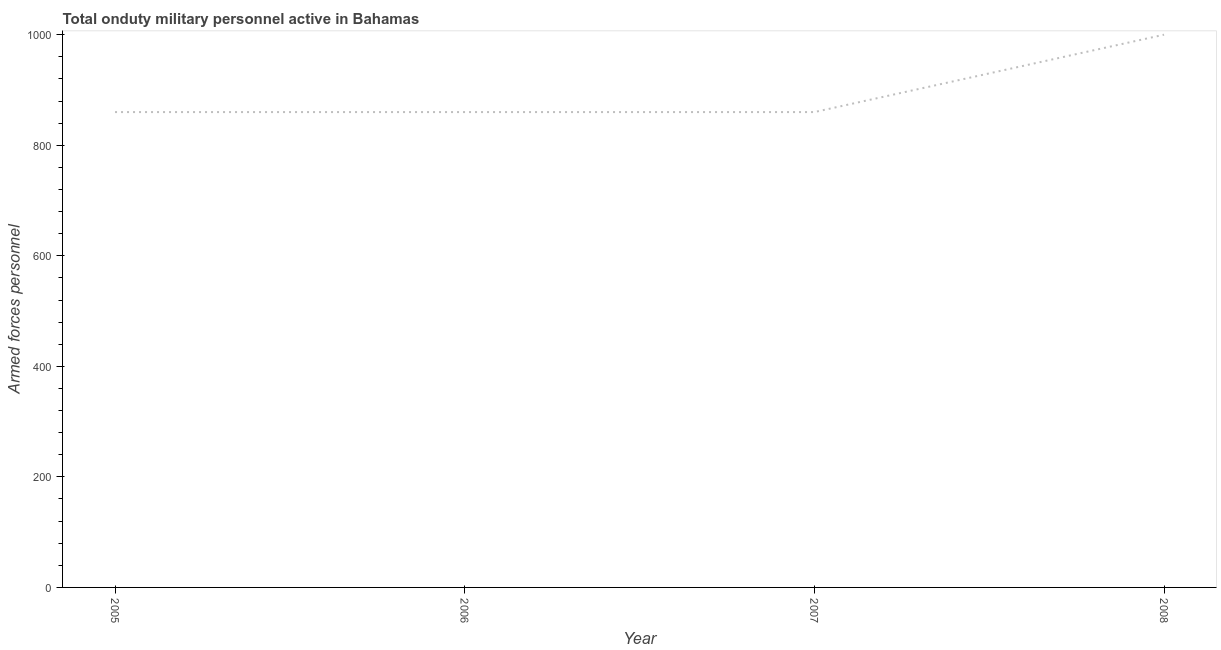What is the number of armed forces personnel in 2006?
Keep it short and to the point. 860. Across all years, what is the maximum number of armed forces personnel?
Your answer should be very brief. 1000. Across all years, what is the minimum number of armed forces personnel?
Ensure brevity in your answer.  860. In which year was the number of armed forces personnel maximum?
Provide a succinct answer. 2008. In which year was the number of armed forces personnel minimum?
Keep it short and to the point. 2005. What is the sum of the number of armed forces personnel?
Your answer should be very brief. 3580. What is the difference between the number of armed forces personnel in 2005 and 2006?
Give a very brief answer. 0. What is the average number of armed forces personnel per year?
Your answer should be compact. 895. What is the median number of armed forces personnel?
Your response must be concise. 860. In how many years, is the number of armed forces personnel greater than 440 ?
Your response must be concise. 4. What is the ratio of the number of armed forces personnel in 2005 to that in 2006?
Give a very brief answer. 1. What is the difference between the highest and the second highest number of armed forces personnel?
Provide a succinct answer. 140. What is the difference between the highest and the lowest number of armed forces personnel?
Make the answer very short. 140. Does the number of armed forces personnel monotonically increase over the years?
Provide a short and direct response. No. Are the values on the major ticks of Y-axis written in scientific E-notation?
Give a very brief answer. No. Does the graph contain any zero values?
Keep it short and to the point. No. What is the title of the graph?
Your response must be concise. Total onduty military personnel active in Bahamas. What is the label or title of the Y-axis?
Make the answer very short. Armed forces personnel. What is the Armed forces personnel of 2005?
Make the answer very short. 860. What is the Armed forces personnel in 2006?
Offer a terse response. 860. What is the Armed forces personnel of 2007?
Offer a terse response. 860. What is the Armed forces personnel of 2008?
Make the answer very short. 1000. What is the difference between the Armed forces personnel in 2005 and 2006?
Your answer should be very brief. 0. What is the difference between the Armed forces personnel in 2005 and 2007?
Provide a short and direct response. 0. What is the difference between the Armed forces personnel in 2005 and 2008?
Your answer should be compact. -140. What is the difference between the Armed forces personnel in 2006 and 2008?
Keep it short and to the point. -140. What is the difference between the Armed forces personnel in 2007 and 2008?
Your answer should be compact. -140. What is the ratio of the Armed forces personnel in 2005 to that in 2006?
Your answer should be compact. 1. What is the ratio of the Armed forces personnel in 2005 to that in 2007?
Make the answer very short. 1. What is the ratio of the Armed forces personnel in 2005 to that in 2008?
Make the answer very short. 0.86. What is the ratio of the Armed forces personnel in 2006 to that in 2008?
Ensure brevity in your answer.  0.86. What is the ratio of the Armed forces personnel in 2007 to that in 2008?
Your answer should be very brief. 0.86. 